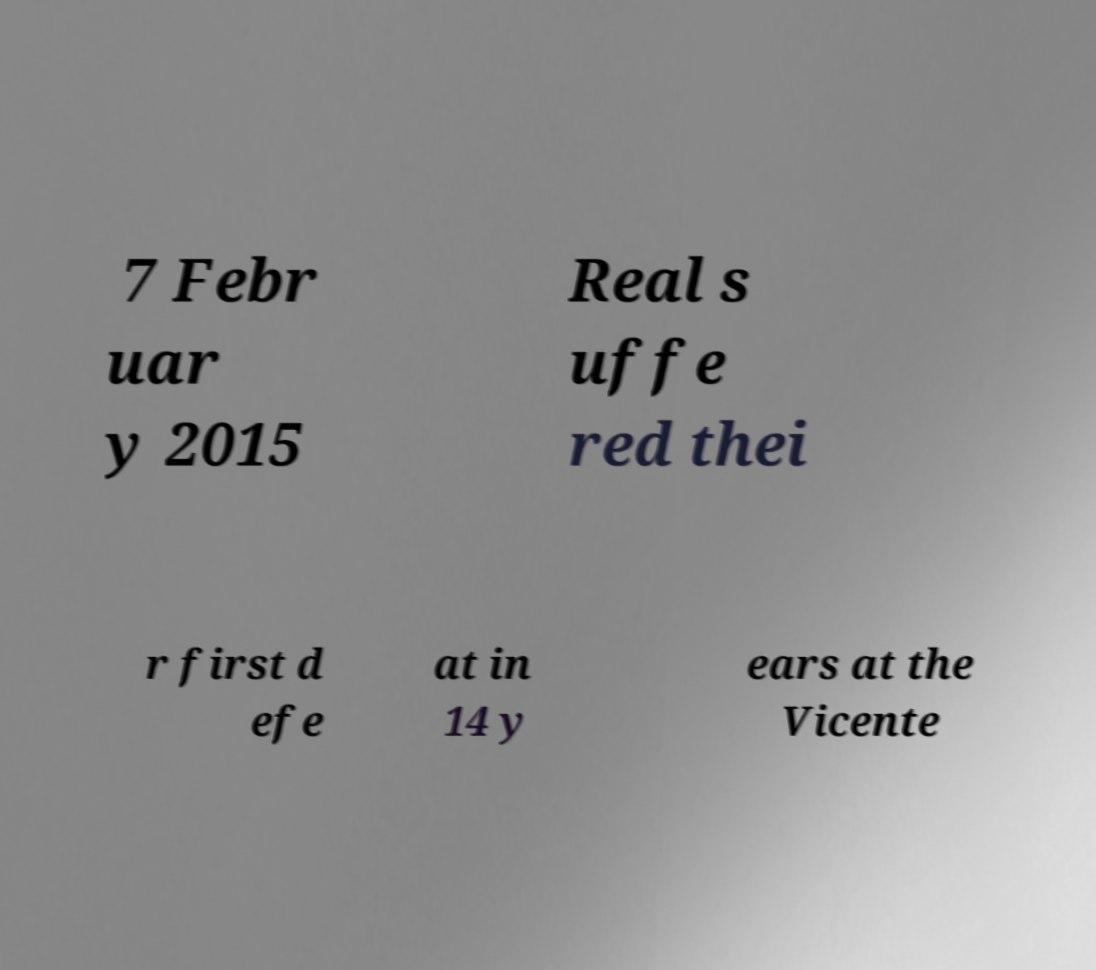I need the written content from this picture converted into text. Can you do that? 7 Febr uar y 2015 Real s uffe red thei r first d efe at in 14 y ears at the Vicente 